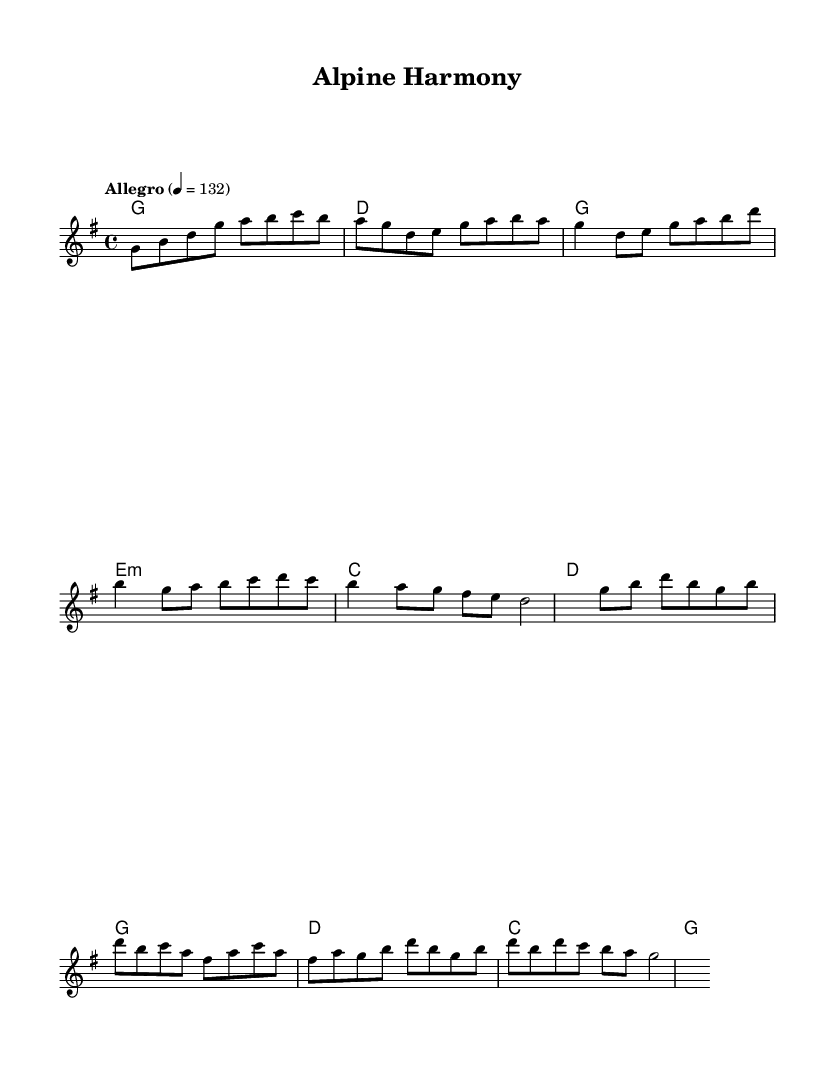What is the key signature of this music? The key signature is G major, indicated by one sharp (F#) in the key signature at the start of the staff.
Answer: G major What is the time signature of this music? The time signature is 4/4, shown at the beginning of the piece with the "4/4" marking, indicating four beats in each measure.
Answer: 4/4 What is the tempo marking for this piece? The tempo marking is Allegro, which is typically fast and lively. It is indicated with "Allegro" and a metronome marking of 132 beats per minute.
Answer: Allegro How many measures are in the chorus section? The chorus consists of four measures. This can be counted directly from the score, where the chorus is visually set apart and includes a specific melodic line.
Answer: 4 What is the first note of the melody? The first note of the melody is G. This can be determined by examining the first note indicated on the staff.
Answer: G What chords are used in the verse? The chords used in the verse are G, E minor, C, and D, these chords are part of the chord progression depicted under the melodies in the score.
Answer: G, E minor, C, D What is the last note of the melody? The last note of the melody is D. This is identifiable by looking at the final note in the last measure of the melody line.
Answer: D 